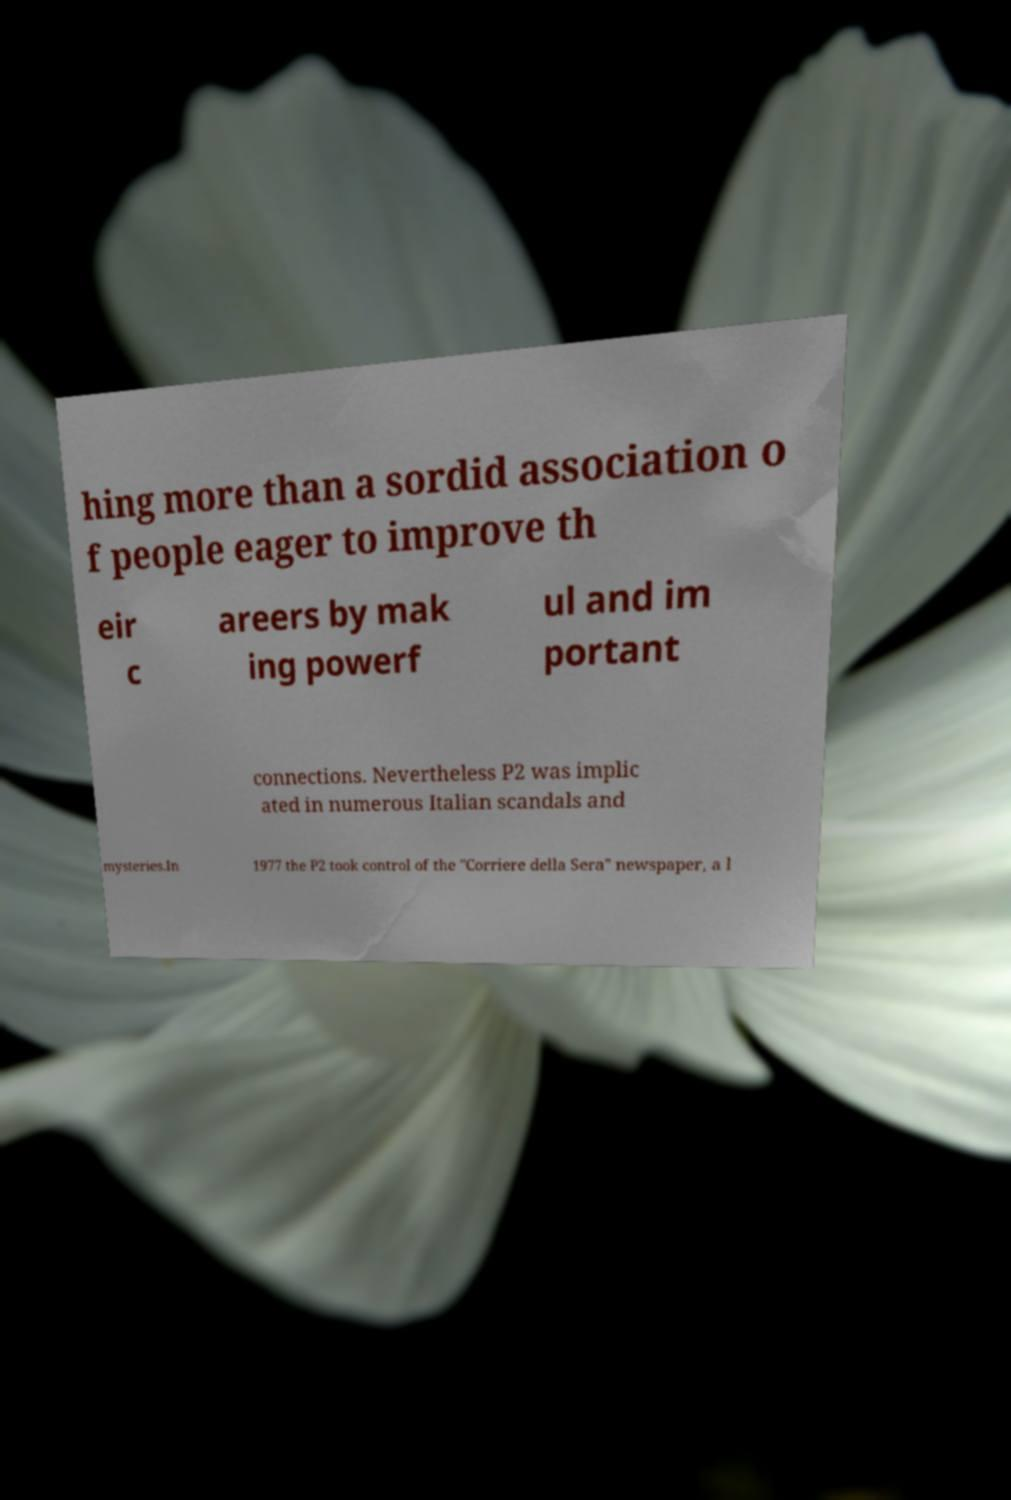There's text embedded in this image that I need extracted. Can you transcribe it verbatim? hing more than a sordid association o f people eager to improve th eir c areers by mak ing powerf ul and im portant connections. Nevertheless P2 was implic ated in numerous Italian scandals and mysteries.In 1977 the P2 took control of the "Corriere della Sera" newspaper, a l 